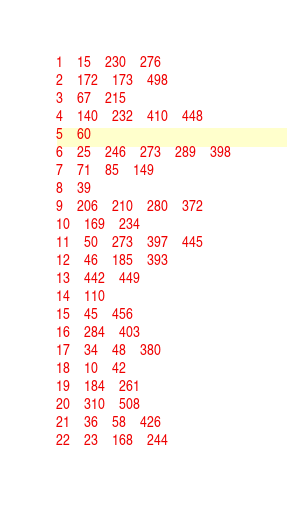Convert code to text. <code><loc_0><loc_0><loc_500><loc_500><_Perl_>1	15	230	276
2	172	173	498
3	67	215
4	140	232	410	448
5	60
6	25	246	273	289	398
7	71	85	149
8	39
9	206	210	280	372
10	169	234
11	50	273	397	445
12	46	185	393
13	442	449
14	110
15	45	456
16	284	403
17	34	48	380
18	10	42
19	184	261
20	310	508
21	36	58	426
22	23	168	244</code> 